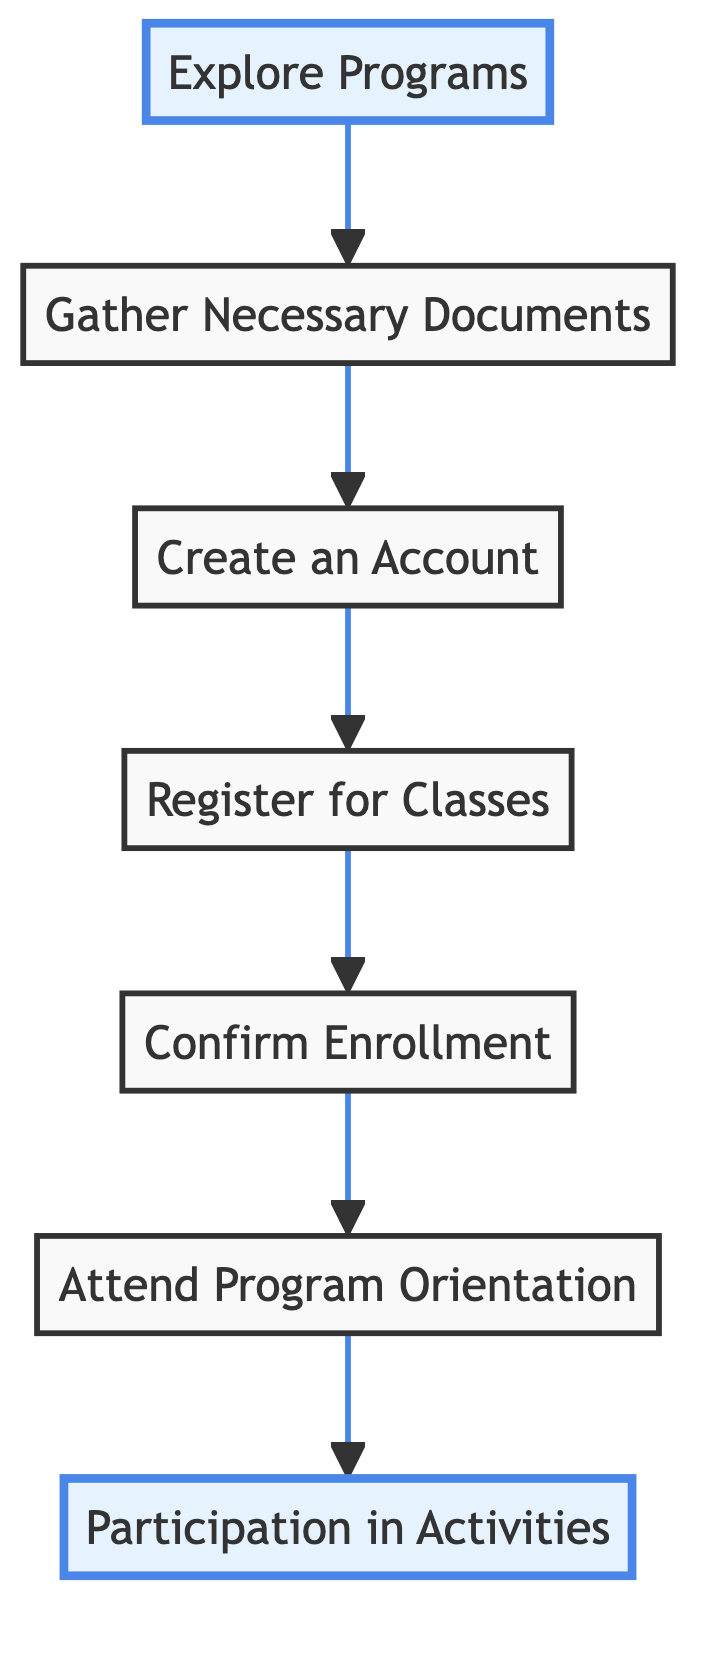What is the first step in the flowchart? The first step in the flowchart is "Explore Programs." This is identified as the bottom node, indicating the initial action before proceeding to gather documents.
Answer: Explore Programs How many total steps are there in the flowchart? There are seven steps in the flowchart, as counted from the bottom node "Explore Programs" to the top node "Participation in Activities."
Answer: 7 What comes after "Register for Classes"? The step that comes after "Register for Classes" is "Confirm Enrollment," which is directly linked above it in the flow.
Answer: Confirm Enrollment Which step directly precedes "Participation in Activities"? The step that directly precedes "Participation in Activities" is "Attend Program Orientation," as it flows upward to the final participation stage.
Answer: Attend Program Orientation What is required before creating an account? Before creating an account, it is necessary to "Gather Necessary Documents," which is the previous step in the process.
Answer: Gather Necessary Documents How is the flow of the diagram organized? The flow of the diagram is organized from bottom to top, starting with actions needed to begin the process and culminating in participation in activities.
Answer: Bottom to top What is the last step in the registration process? The last step in the registration process is "Participation in Activities," which signifies the conclusion of the steps leading to involvement in programs.
Answer: Participation in Activities Which nodes are highlighted in the diagram? The highlighted nodes in the diagram are "Explore Programs" and "Participation in Activities," indicating significant points in the flow.
Answer: Explore Programs, Participation in Activities How many documents are necessary to gather? The exact number of documents required is not specified in the diagram, only that "Gather Necessary Documents" is a step in the process. Thus, it's assumed that the number can vary based on individual needs.
Answer: Not specified 